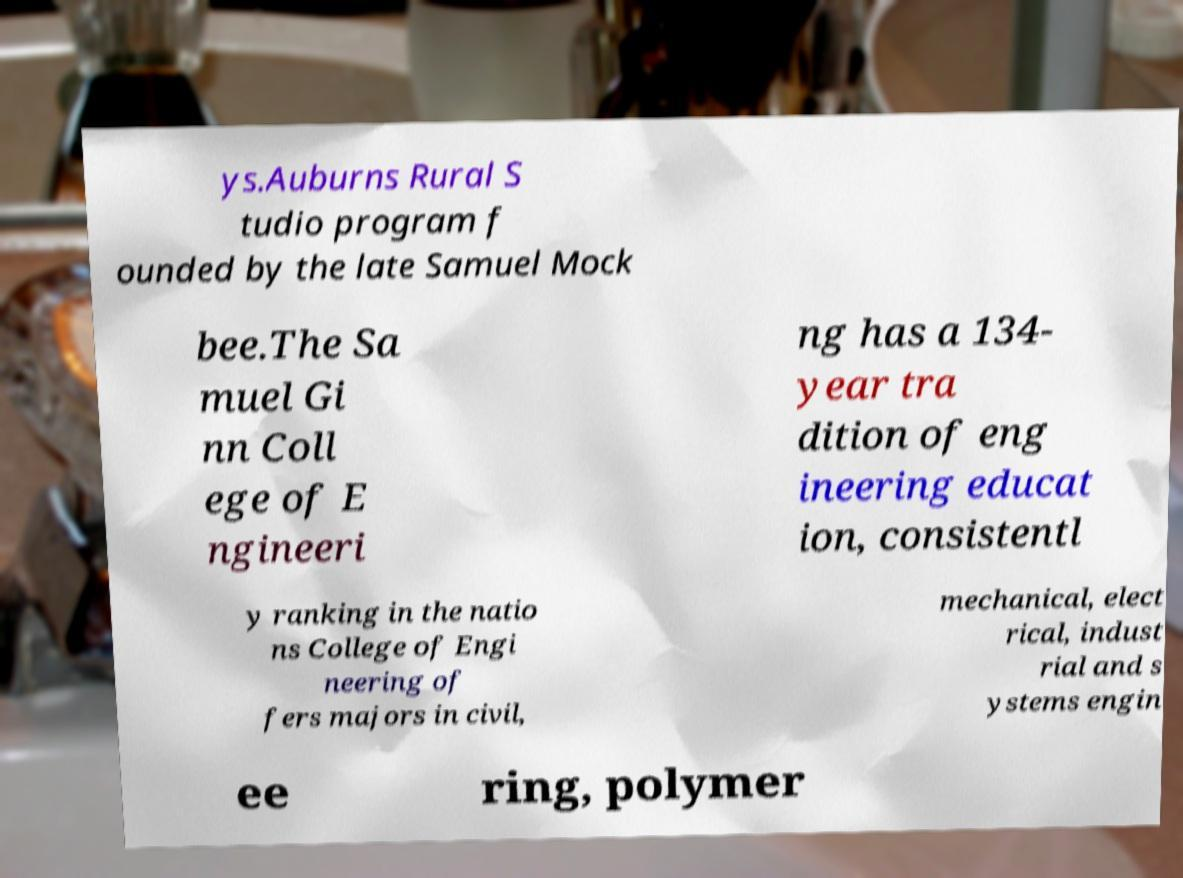There's text embedded in this image that I need extracted. Can you transcribe it verbatim? ys.Auburns Rural S tudio program f ounded by the late Samuel Mock bee.The Sa muel Gi nn Coll ege of E ngineeri ng has a 134- year tra dition of eng ineering educat ion, consistentl y ranking in the natio ns College of Engi neering of fers majors in civil, mechanical, elect rical, indust rial and s ystems engin ee ring, polymer 